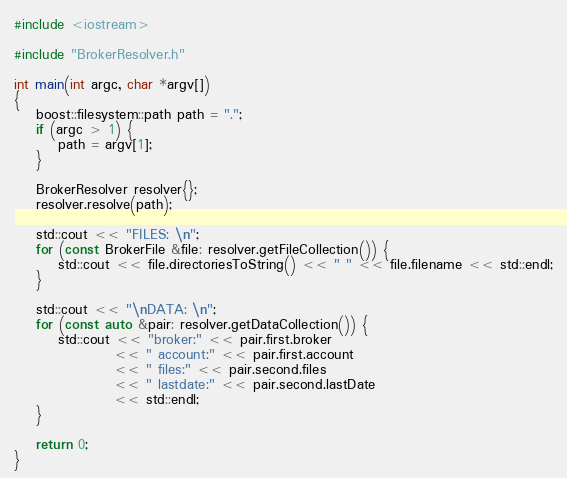<code> <loc_0><loc_0><loc_500><loc_500><_C++_>#include <iostream>

#include "BrokerResolver.h"

int main(int argc, char *argv[])
{
    boost::filesystem::path path = ".";
    if (argc > 1) {
        path = argv[1];
    }

    BrokerResolver resolver{};
    resolver.resolve(path);

    std::cout << "FILES: \n";
    for (const BrokerFile &file: resolver.getFileCollection()) {
        std::cout << file.directoriesToString() << " " << file.filename << std::endl;
    }

    std::cout << "\nDATA: \n";
    for (const auto &pair: resolver.getDataCollection()) {
        std::cout << "broker:" << pair.first.broker
                  << " account:" << pair.first.account
                  << " files:" << pair.second.files
                  << " lastdate:" << pair.second.lastDate
                  << std::endl;
    }

    return 0;
}</code> 